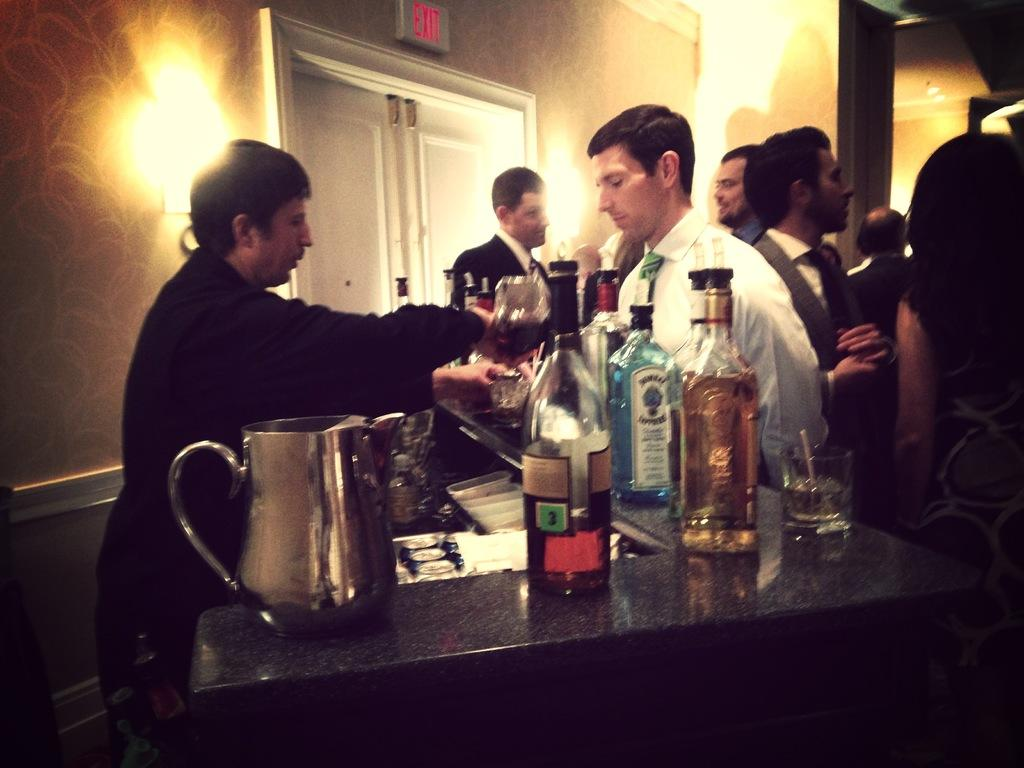<image>
Render a clear and concise summary of the photo. two men next to vodka bottles and an exit sign 